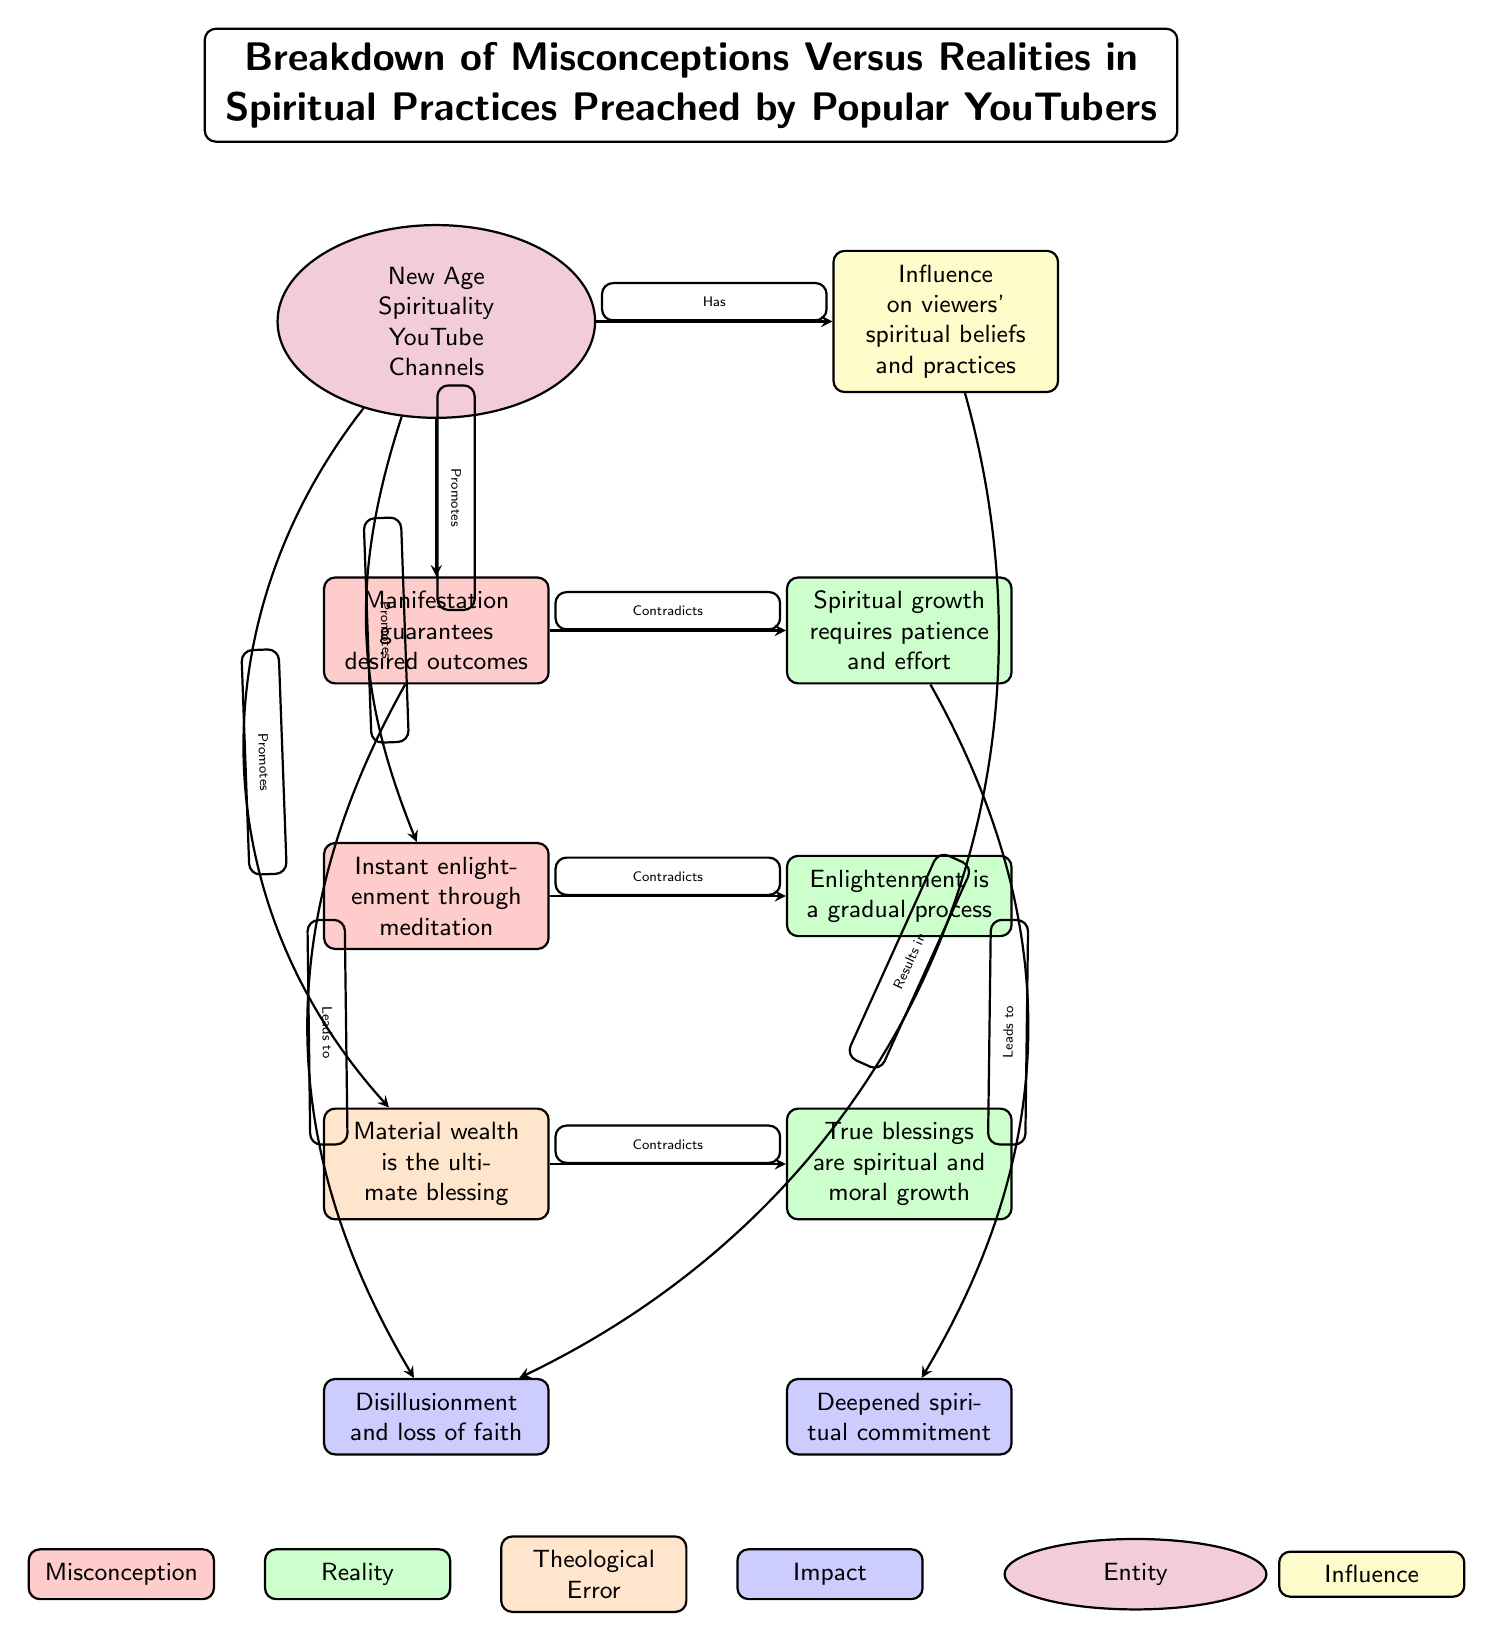What is the misconception about manifestation? The diagram identifies the specific misconception as "Manifestation guarantees desired outcomes" in the designated node.
Answer: Manifestation guarantees desired outcomes What leads to disillusionment and loss of faith? The diagram indicates that the misconception "Material wealth is the ultimate blessing" leads to the impact labeled "Disillusionment and loss of faith" through the arrow connecting them.
Answer: Material wealth is the ultimate blessing How many realities are presented in the diagram? By examining the nodes labeled as realities, there are a total of three realities stated, which are: "Spiritual growth requires patience and effort," "Enlightenment is a gradual process," and "True blessings are spiritual and moral growth."
Answer: 3 What does the influence on viewers result in? The diagram shows that the influence on viewers' spiritual beliefs and practices results in "Disillusionment and loss of faith," as indicated by the arrow linking the influence node to that impact.
Answer: Disillusionment and loss of faith Which theological error is associated with instant enlightenment through meditation? The diagram states that the theological error linked to the misconception "Instant enlightenment through meditation" is displayed as "Enlightenment is a gradual process." This implies that the actual reality contradicts the misconception.
Answer: Enlightenment is a gradual process What are the colors used to represent theological errors in the diagram? The diagram uses a specific color for theological errors, which is orange, as indicated in the legend and the node style for errors.
Answer: Orange How many impacts are identified in the diagram? The diagram displays two distinct impacts labeled: "Disillusionment and loss of faith" and "Deepened spiritual commitment," which indicates a total of two impacts identified in the visual representation.
Answer: 2 What misconception is promoted by New Age Spirituality YouTube Channels? The misconception "Instant enlightenment through meditation" is promoted, as shown by the arrows emanating from the "New Age Spirituality YouTube Channels" node to that specific misconception.
Answer: Instant enlightenment through meditation Which entity is promoting the misconceptions? The diagram identifies "New Age Spirituality YouTube Channels" as the entity that is promoting various misconceptions pertaining to spiritual practices as represented in the node.
Answer: New Age Spirituality YouTube Channels 